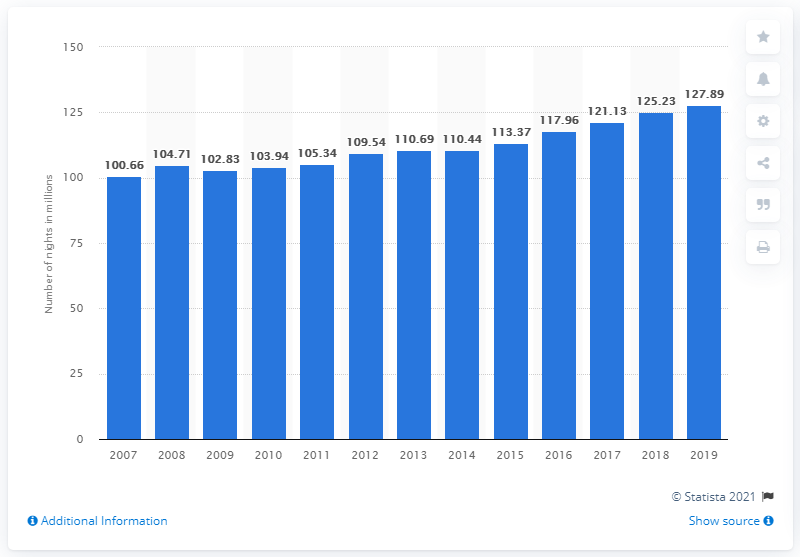Mention a couple of crucial points in this snapshot. During the period between 2007 and 2019, a total of 127.89 nights were spent at tourist accommodation establishments in Austria. 